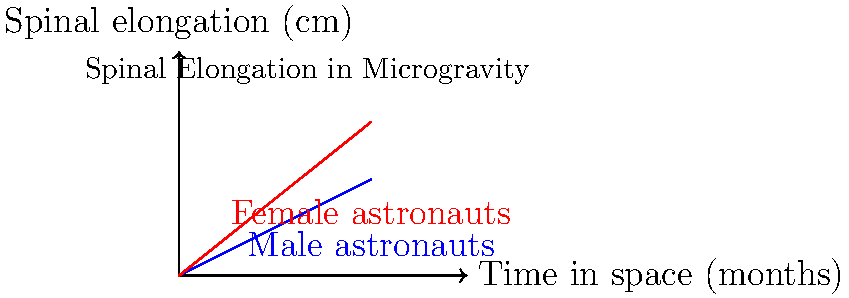Based on the graph showing spinal elongation in microgravity over time, what conclusion can be drawn about the difference in spinal decompression between male and female astronauts during long-term space missions? To answer this question, we need to analyze the graph and compare the trends for male and female astronauts:

1. The blue line represents male astronauts, while the red line represents female astronauts.

2. Both lines show an upward trend, indicating that spinal elongation increases for both genders over time in microgravity.

3. Comparing the slopes of the two lines:
   - The red line (female astronauts) has a steeper slope than the blue line (male astronauts).
   - This indicates that the rate of spinal elongation is greater for female astronauts.

4. At the 4-month mark:
   - Male astronauts experience approximately 2 cm of spinal elongation.
   - Female astronauts experience approximately 3.2 cm of spinal elongation.

5. The difference in spinal elongation between female and male astronauts increases over time, suggesting that female astronauts may be more susceptible to spinal decompression in microgravity.

This observation aligns with some studies suggesting that female astronauts may experience more significant physiological changes in space, possibly due to differences in muscle mass, bone density, or hormonal factors. However, it's important to note that individual variations and other factors may also play a role in spinal decompression during long-term space missions.
Answer: Female astronauts experience greater spinal elongation than male astronauts during long-term space missions. 